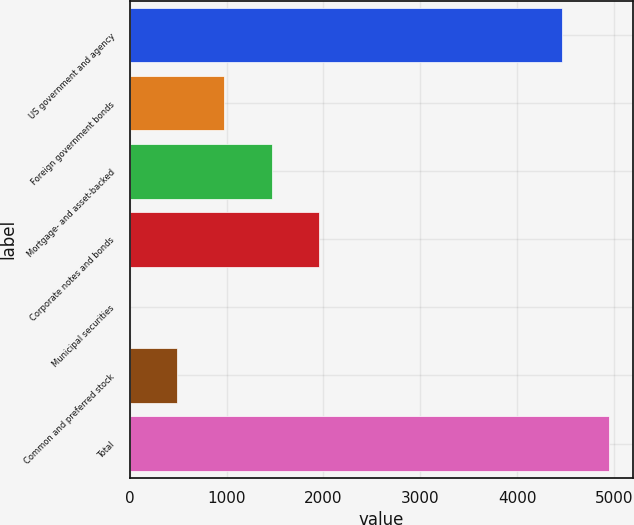Convert chart. <chart><loc_0><loc_0><loc_500><loc_500><bar_chart><fcel>US government and agency<fcel>Foreign government bonds<fcel>Mortgage- and asset-backed<fcel>Corporate notes and bonds<fcel>Municipal securities<fcel>Common and preferred stock<fcel>Total<nl><fcel>4459<fcel>978<fcel>1465.38<fcel>1952.76<fcel>3.24<fcel>490.62<fcel>4946.38<nl></chart> 